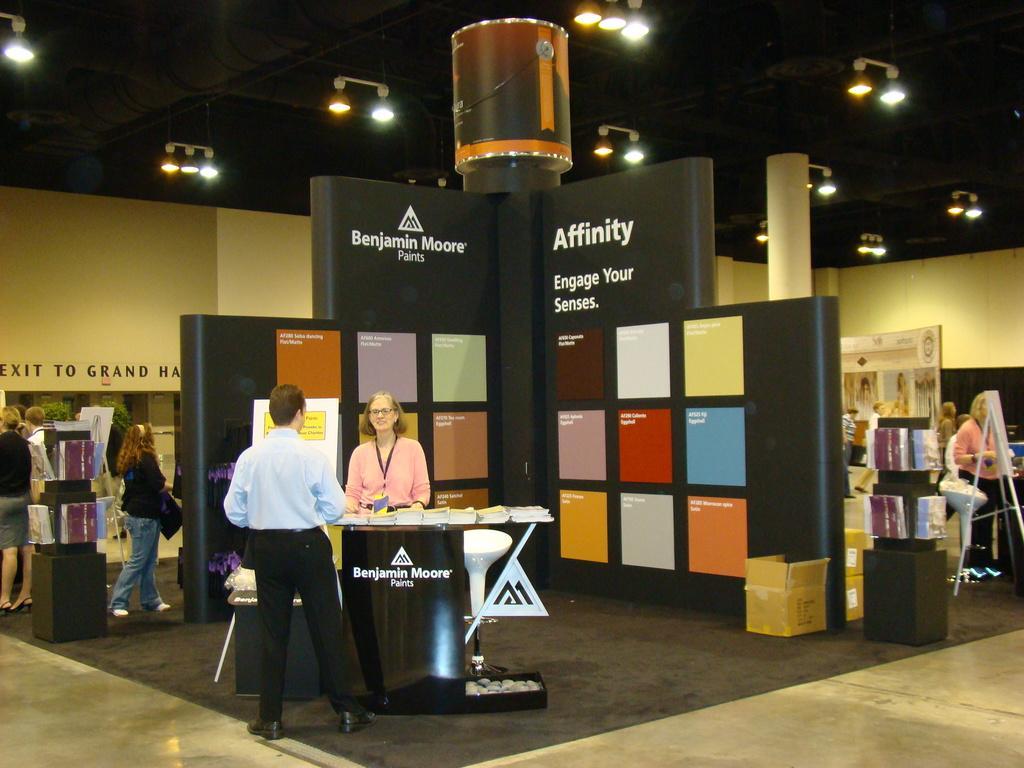How would you summarize this image in a sentence or two? In the given image we can see there are many people. This is a podium and chair. There are lights above. This is a box. 